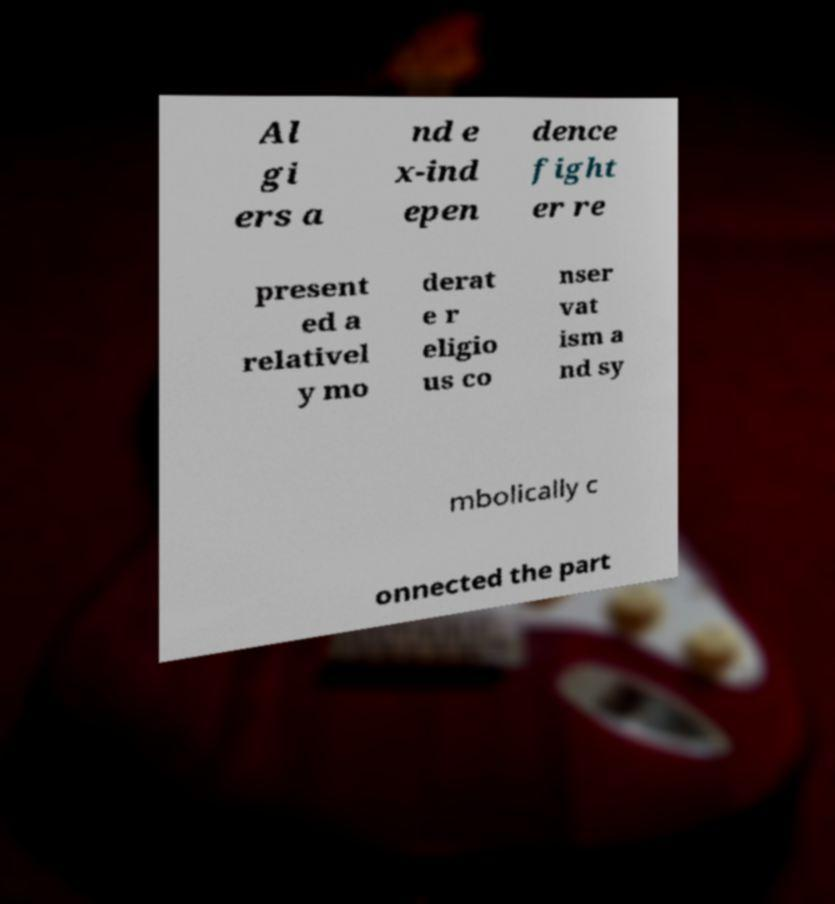Could you assist in decoding the text presented in this image and type it out clearly? Al gi ers a nd e x-ind epen dence fight er re present ed a relativel y mo derat e r eligio us co nser vat ism a nd sy mbolically c onnected the part 